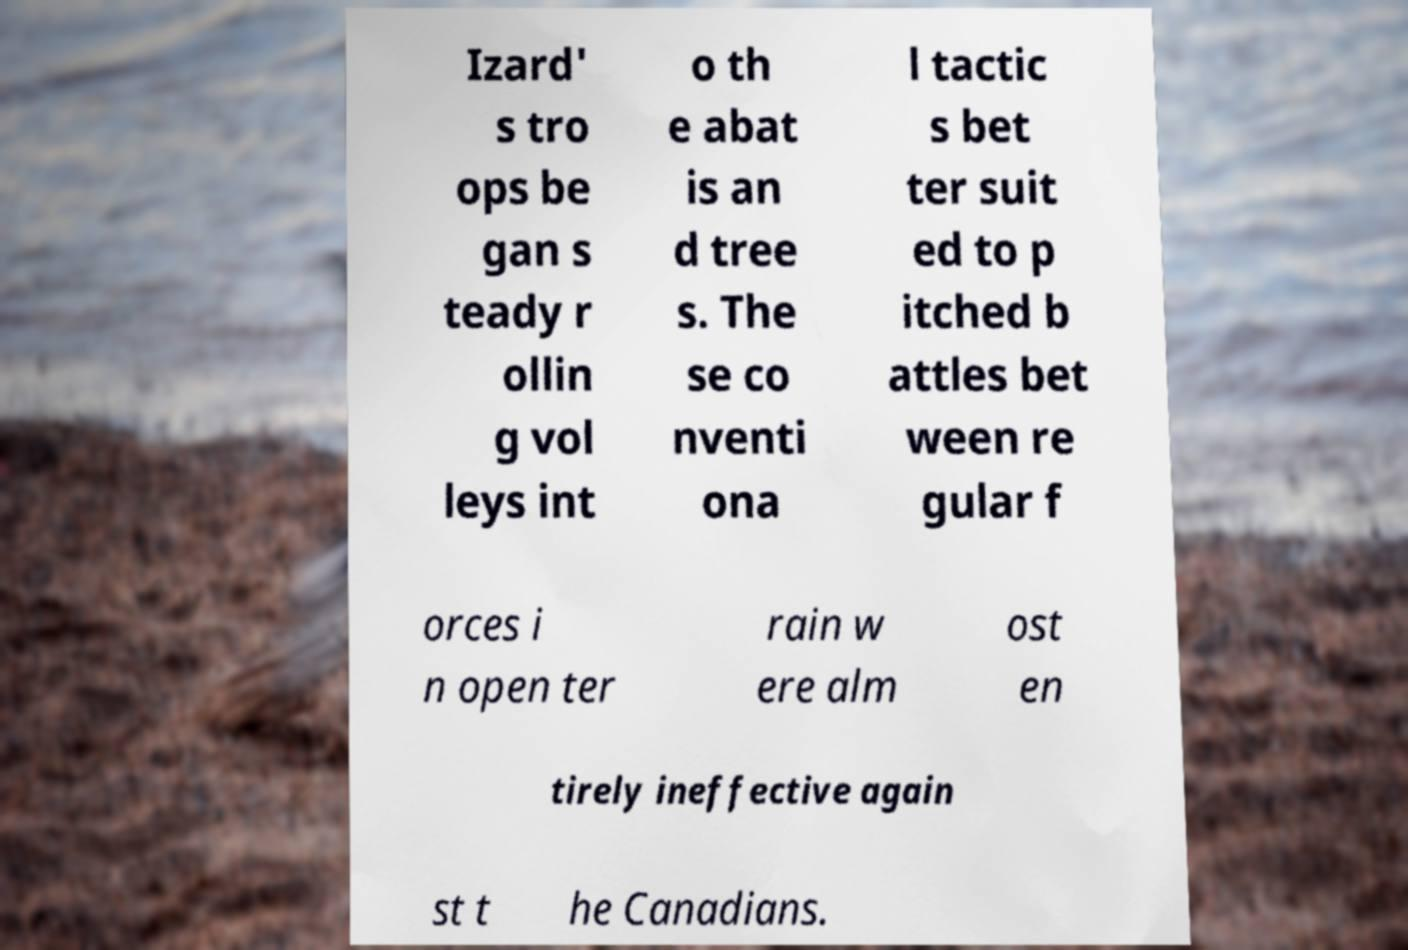Could you extract and type out the text from this image? Izard' s tro ops be gan s teady r ollin g vol leys int o th e abat is an d tree s. The se co nventi ona l tactic s bet ter suit ed to p itched b attles bet ween re gular f orces i n open ter rain w ere alm ost en tirely ineffective again st t he Canadians. 